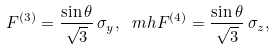<formula> <loc_0><loc_0><loc_500><loc_500>F ^ { ( 3 ) } = \frac { \sin \theta } { \sqrt { 3 } } \, \sigma _ { y } , \ m h F ^ { ( 4 ) } = \frac { \sin \theta } { \sqrt { 3 } } \, \sigma _ { z } ,</formula> 